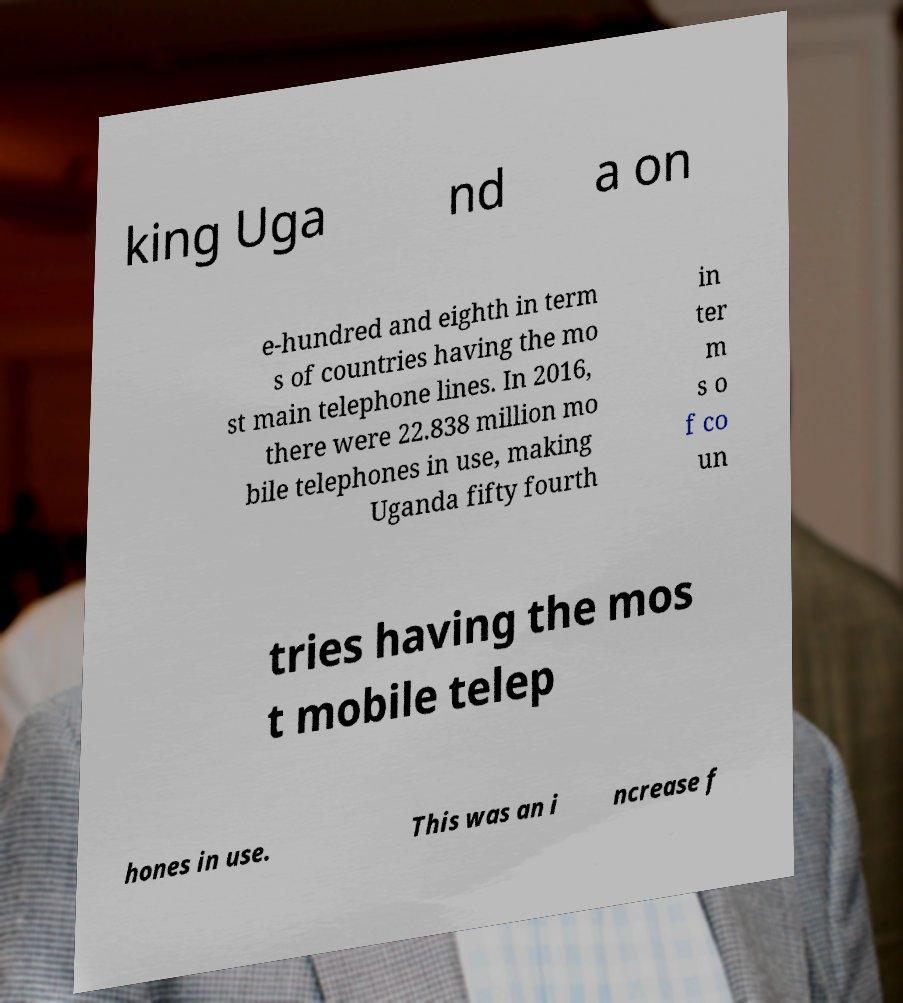I need the written content from this picture converted into text. Can you do that? king Uga nd a on e-hundred and eighth in term s of countries having the mo st main telephone lines. In 2016, there were 22.838 million mo bile telephones in use, making Uganda fifty fourth in ter m s o f co un tries having the mos t mobile telep hones in use. This was an i ncrease f 